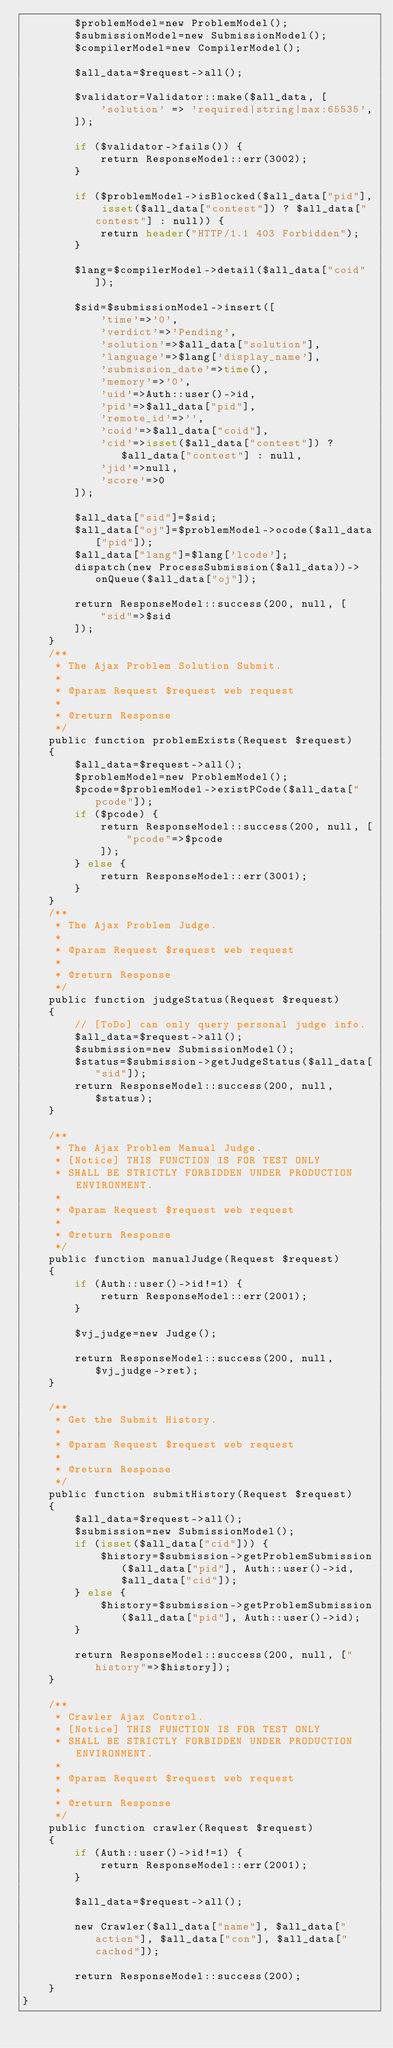Convert code to text. <code><loc_0><loc_0><loc_500><loc_500><_PHP_>        $problemModel=new ProblemModel();
        $submissionModel=new SubmissionModel();
        $compilerModel=new CompilerModel();

        $all_data=$request->all();

        $validator=Validator::make($all_data, [
            'solution' => 'required|string|max:65535',
        ]);

        if ($validator->fails()) {
            return ResponseModel::err(3002);
        }

        if ($problemModel->isBlocked($all_data["pid"], isset($all_data["contest"]) ? $all_data["contest"] : null)) {
            return header("HTTP/1.1 403 Forbidden");
        }

        $lang=$compilerModel->detail($all_data["coid"]);

        $sid=$submissionModel->insert([
            'time'=>'0',
            'verdict'=>'Pending',
            'solution'=>$all_data["solution"],
            'language'=>$lang['display_name'],
            'submission_date'=>time(),
            'memory'=>'0',
            'uid'=>Auth::user()->id,
            'pid'=>$all_data["pid"],
            'remote_id'=>'',
            'coid'=>$all_data["coid"],
            'cid'=>isset($all_data["contest"]) ? $all_data["contest"] : null,
            'jid'=>null,
            'score'=>0
        ]);

        $all_data["sid"]=$sid;
        $all_data["oj"]=$problemModel->ocode($all_data["pid"]);
        $all_data["lang"]=$lang['lcode'];
        dispatch(new ProcessSubmission($all_data))->onQueue($all_data["oj"]);

        return ResponseModel::success(200, null, [
            "sid"=>$sid
        ]);
    }
    /**
     * The Ajax Problem Solution Submit.
     *
     * @param Request $request web request
     *
     * @return Response
     */
    public function problemExists(Request $request)
    {
        $all_data=$request->all();
        $problemModel=new ProblemModel();
        $pcode=$problemModel->existPCode($all_data["pcode"]);
        if ($pcode) {
            return ResponseModel::success(200, null, [
                "pcode"=>$pcode
            ]);
        } else {
            return ResponseModel::err(3001);
        }
    }
    /**
     * The Ajax Problem Judge.
     *
     * @param Request $request web request
     *
     * @return Response
     */
    public function judgeStatus(Request $request)
    {
        // [ToDo] can only query personal judge info.
        $all_data=$request->all();
        $submission=new SubmissionModel();
        $status=$submission->getJudgeStatus($all_data["sid"]);
        return ResponseModel::success(200, null, $status);
    }

    /**
     * The Ajax Problem Manual Judge.
     * [Notice] THIS FUNCTION IS FOR TEST ONLY
     * SHALL BE STRICTLY FORBIDDEN UNDER PRODUCTION ENVIRONMENT.
     *
     * @param Request $request web request
     *
     * @return Response
     */
    public function manualJudge(Request $request)
    {
        if (Auth::user()->id!=1) {
            return ResponseModel::err(2001);
        }

        $vj_judge=new Judge();

        return ResponseModel::success(200, null, $vj_judge->ret);
    }

    /**
     * Get the Submit History.
     *
     * @param Request $request web request
     *
     * @return Response
     */
    public function submitHistory(Request $request)
    {
        $all_data=$request->all();
        $submission=new SubmissionModel();
        if (isset($all_data["cid"])) {
            $history=$submission->getProblemSubmission($all_data["pid"], Auth::user()->id, $all_data["cid"]);
        } else {
            $history=$submission->getProblemSubmission($all_data["pid"], Auth::user()->id);
        }

        return ResponseModel::success(200, null, ["history"=>$history]);
    }

    /**
     * Crawler Ajax Control.
     * [Notice] THIS FUNCTION IS FOR TEST ONLY
     * SHALL BE STRICTLY FORBIDDEN UNDER PRODUCTION ENVIRONMENT.
     *
     * @param Request $request web request
     *
     * @return Response
     */
    public function crawler(Request $request)
    {
        if (Auth::user()->id!=1) {
            return ResponseModel::err(2001);
        }

        $all_data=$request->all();

        new Crawler($all_data["name"], $all_data["action"], $all_data["con"], $all_data["cached"]);

        return ResponseModel::success(200);
    }
}
</code> 